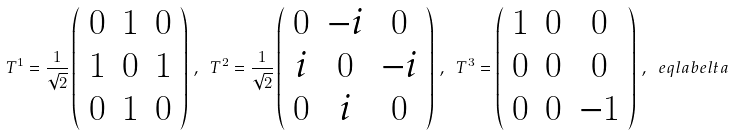<formula> <loc_0><loc_0><loc_500><loc_500>T ^ { 1 } = \frac { 1 } { \sqrt { 2 } } \left ( \begin{array} { c c c } 0 & 1 & 0 \\ 1 & 0 & 1 \\ 0 & 1 & 0 \end{array} \right ) \, , \ T ^ { 2 } = \frac { 1 } { \sqrt { 2 } } \left ( \begin{array} { c c c } 0 & - i & 0 \\ i & 0 & - i \\ 0 & i & 0 \end{array} \right ) \, , \ T ^ { 3 } = \left ( \begin{array} { c c c } 1 & 0 & 0 \\ 0 & 0 & 0 \\ 0 & 0 & - 1 \end{array} \right ) \, , \ e q l a b e l { t a }</formula> 